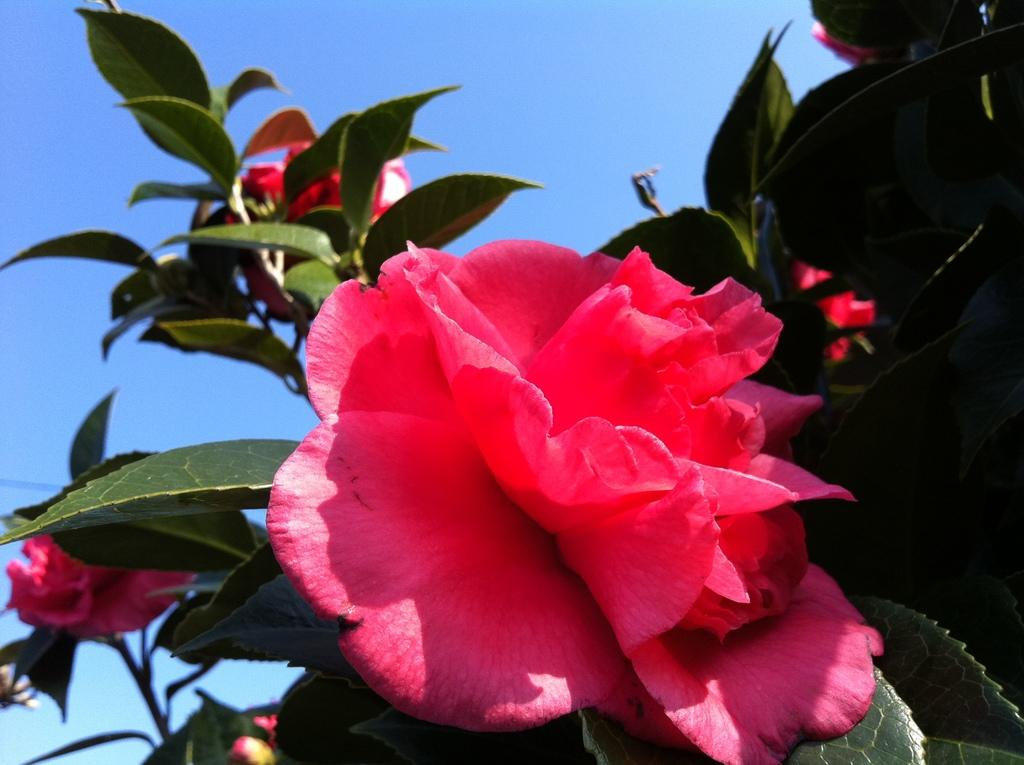What type of plant is present in the image? There are flowers on a plant in the image. What can be seen in the background of the image? The sky is visible in the image. How would you describe the sky in the image? The sky appears cloudy in the image. What is the tax rate for the flowers in the image? There is no tax rate mentioned or implied in the image, as it is a photograph of flowers on a plant. 